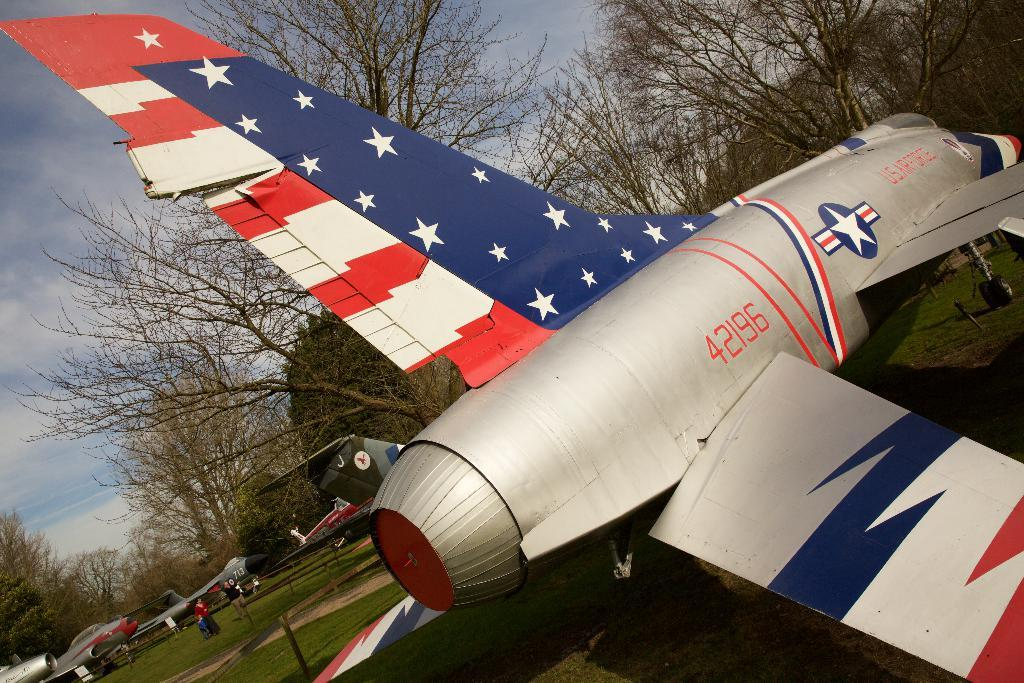<image>
Give a short and clear explanation of the subsequent image. The identifying number of the red, white and blue airplane is 42196. 